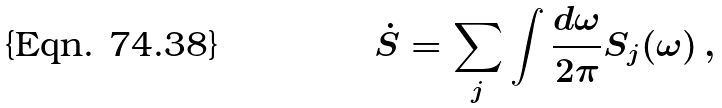<formula> <loc_0><loc_0><loc_500><loc_500>\dot { S } = \sum _ { j } \int \frac { d \omega } { 2 \pi } S _ { j } ( \omega ) \, ,</formula> 